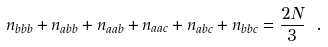Convert formula to latex. <formula><loc_0><loc_0><loc_500><loc_500>n _ { b b b } + n _ { a b b } + n _ { a a b } + n _ { a a c } + n _ { a b c } + n _ { b b c } = \frac { 2 N } { 3 } \ .</formula> 